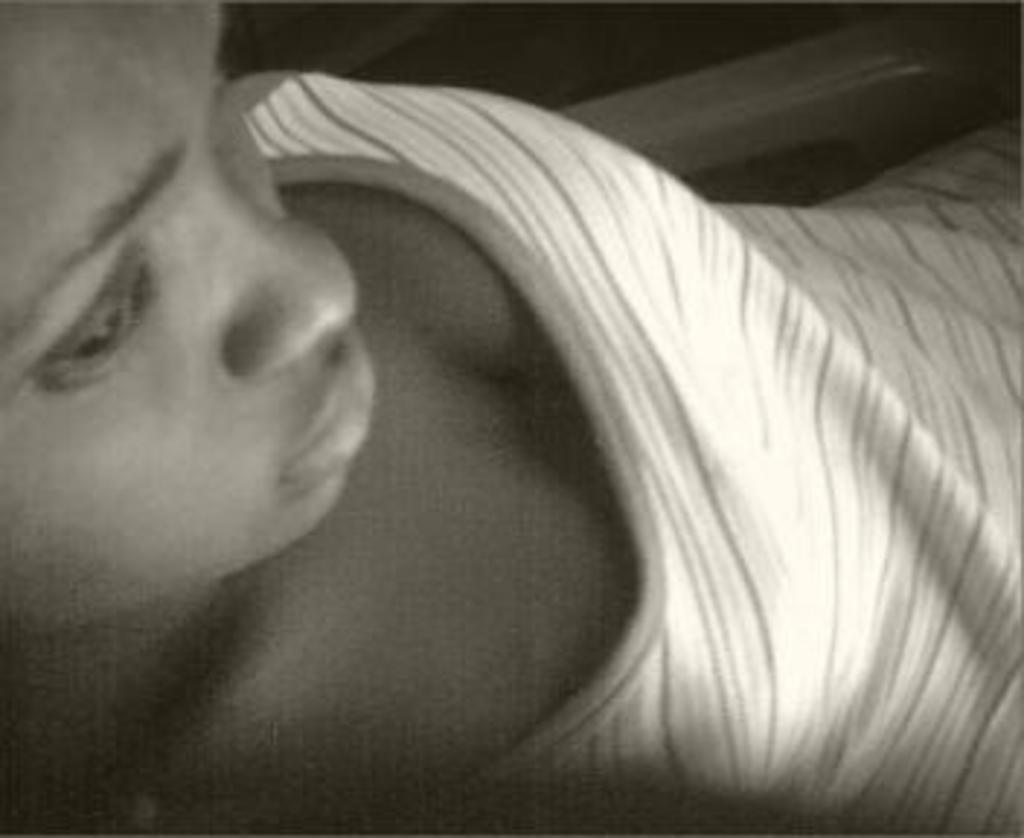What is the main subject of the image? The main subject of the image is the face of a person. What type of gate can be seen in the image? There is no gate present in the image; it only contains the face of a person. 